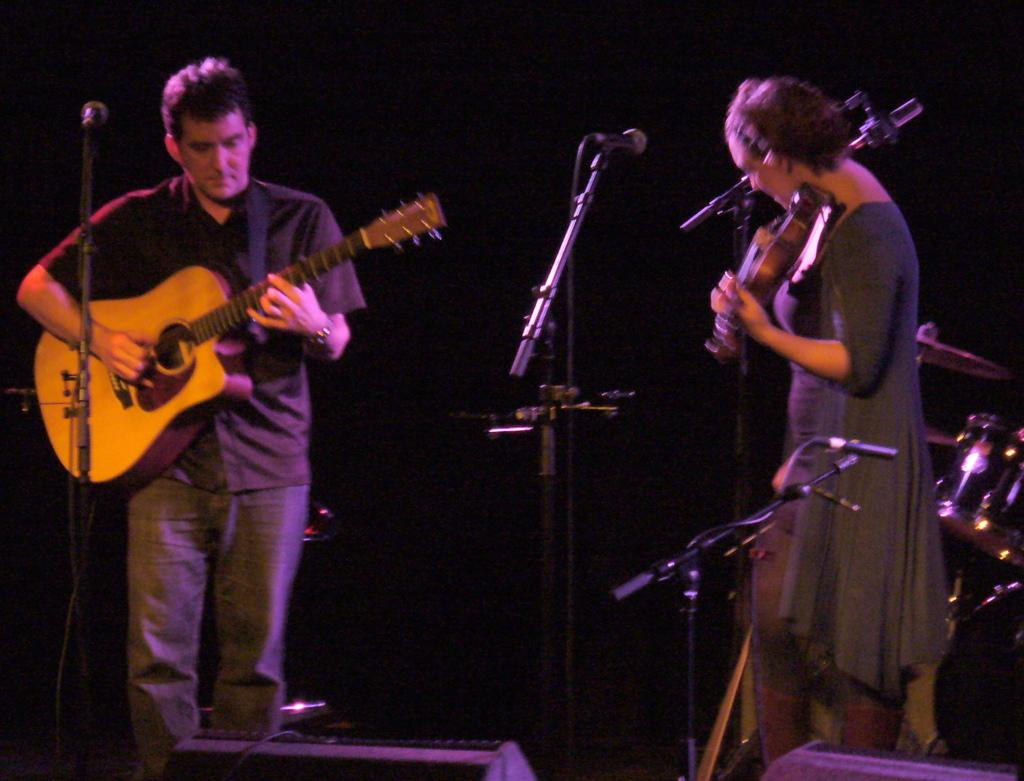How many people are in the image? There are two persons in the image. What are the persons doing in the image? One person is playing a guitar, and both persons are standing on the floor. What objects are present in the image that are related to music? There are microphones and musical instruments in the image. What type of blade can be seen in the image? There is no blade present in the image. Is the image taken in a library? The provided facts do not mention a library, so we cannot determine if the image was taken in one. 